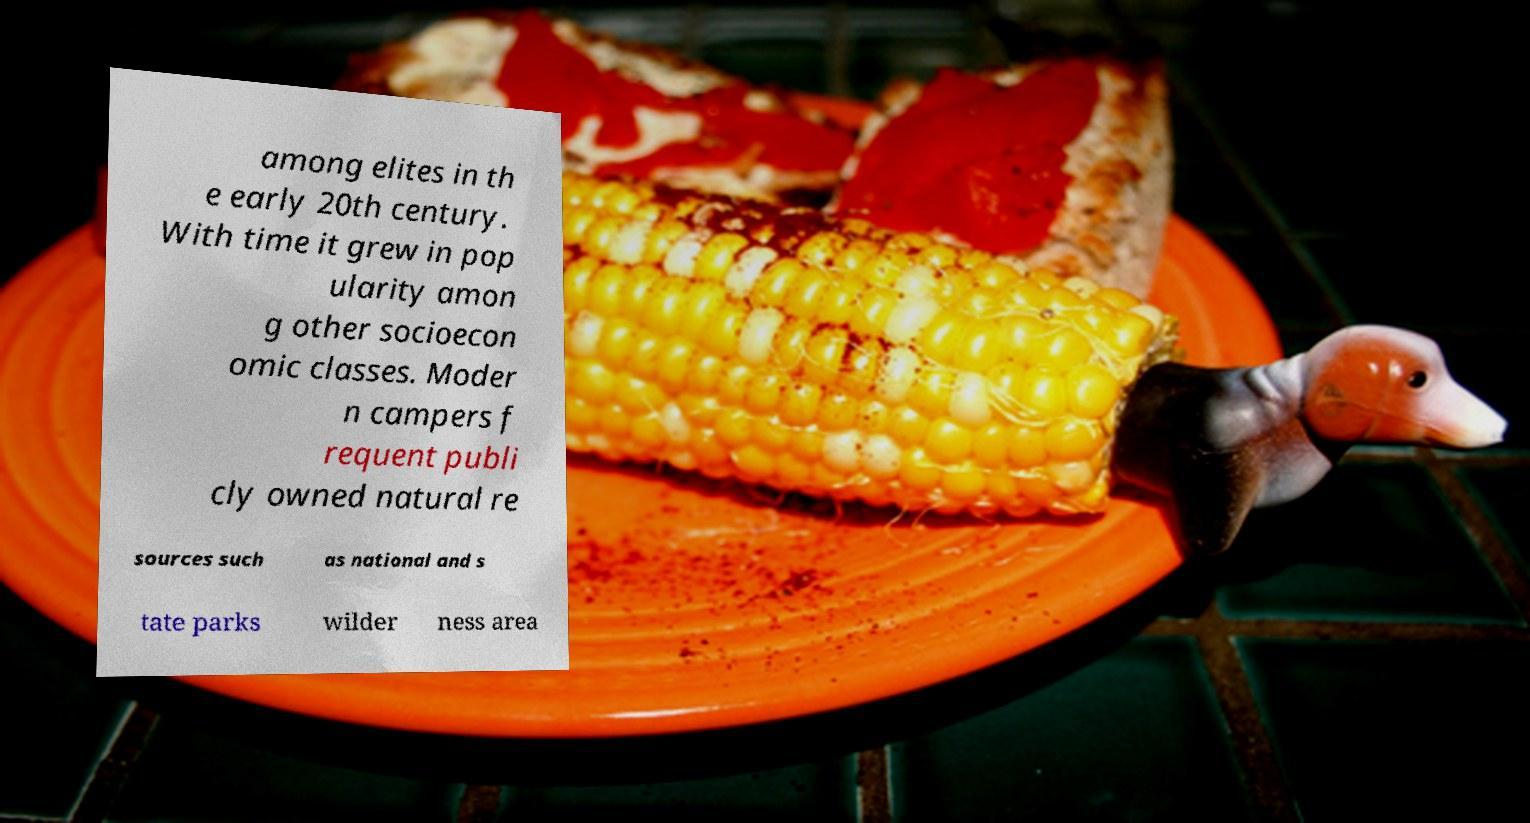Please read and relay the text visible in this image. What does it say? among elites in th e early 20th century. With time it grew in pop ularity amon g other socioecon omic classes. Moder n campers f requent publi cly owned natural re sources such as national and s tate parks wilder ness area 